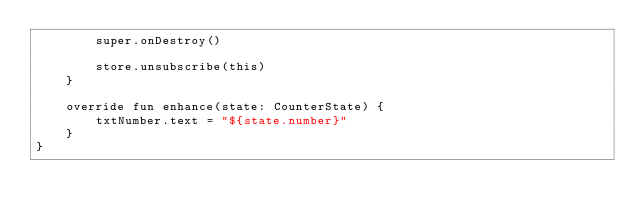<code> <loc_0><loc_0><loc_500><loc_500><_Kotlin_>        super.onDestroy()

        store.unsubscribe(this)
    }

    override fun enhance(state: CounterState) {
        txtNumber.text = "${state.number}"
    }
}
</code> 